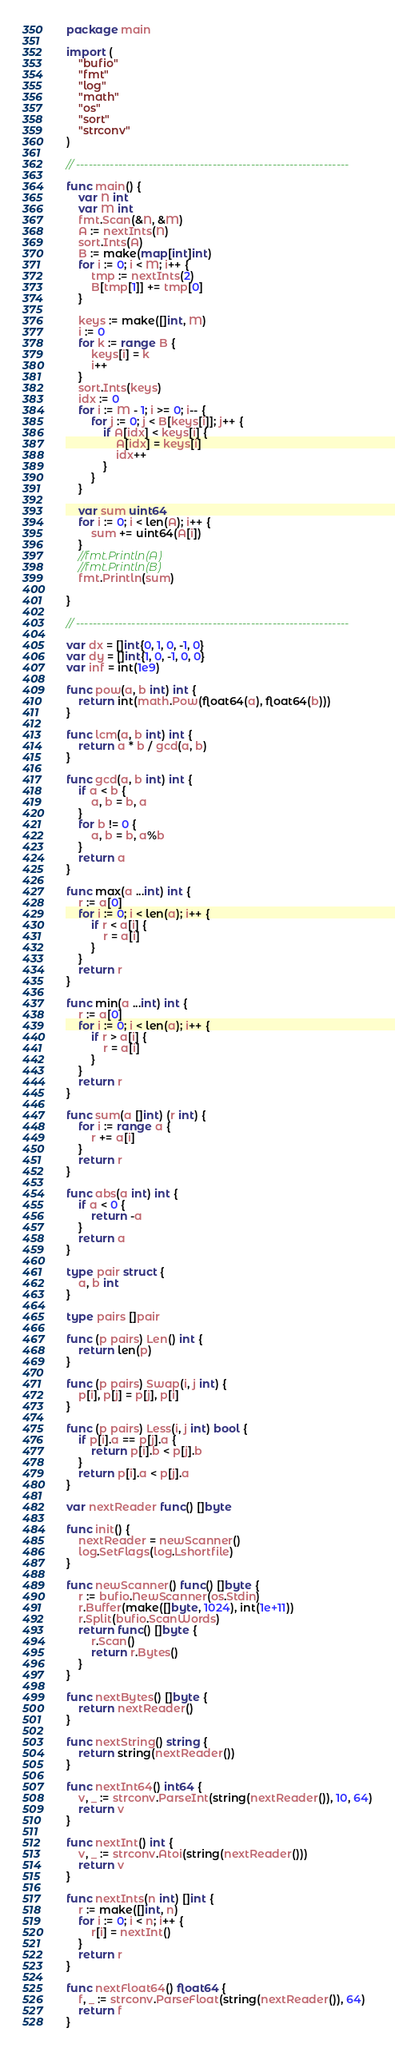<code> <loc_0><loc_0><loc_500><loc_500><_Go_>package main

import (
	"bufio"
	"fmt"
	"log"
	"math"
	"os"
	"sort"
	"strconv"
)

// ----------------------------------------------------------------

func main() {
	var N int
	var M int
	fmt.Scan(&N, &M)
	A := nextInts(N)
	sort.Ints(A)
	B := make(map[int]int)
	for i := 0; i < M; i++ {
		tmp := nextInts(2)
		B[tmp[1]] += tmp[0]
	}

	keys := make([]int, M)
	i := 0
	for k := range B {
		keys[i] = k
		i++
	}
	sort.Ints(keys)
	idx := 0
	for i := M - 1; i >= 0; i-- {
		for j := 0; j < B[keys[i]]; j++ {
			if A[idx] < keys[i] {
				A[idx] = keys[i]
				idx++
			}
		}
	}

	var sum uint64
	for i := 0; i < len(A); i++ {
		sum += uint64(A[i])
	}
	//fmt.Println(A)
	//fmt.Println(B)
	fmt.Println(sum)

}

// ----------------------------------------------------------------

var dx = []int{0, 1, 0, -1, 0}
var dy = []int{1, 0, -1, 0, 0}
var inf = int(1e9)

func pow(a, b int) int {
	return int(math.Pow(float64(a), float64(b)))
}

func lcm(a, b int) int {
	return a * b / gcd(a, b)
}

func gcd(a, b int) int {
	if a < b {
		a, b = b, a
	}
	for b != 0 {
		a, b = b, a%b
	}
	return a
}

func max(a ...int) int {
	r := a[0]
	for i := 0; i < len(a); i++ {
		if r < a[i] {
			r = a[i]
		}
	}
	return r
}

func min(a ...int) int {
	r := a[0]
	for i := 0; i < len(a); i++ {
		if r > a[i] {
			r = a[i]
		}
	}
	return r
}

func sum(a []int) (r int) {
	for i := range a {
		r += a[i]
	}
	return r
}

func abs(a int) int {
	if a < 0 {
		return -a
	}
	return a
}

type pair struct {
	a, b int
}

type pairs []pair

func (p pairs) Len() int {
	return len(p)
}

func (p pairs) Swap(i, j int) {
	p[i], p[j] = p[j], p[i]
}

func (p pairs) Less(i, j int) bool {
	if p[i].a == p[j].a {
		return p[i].b < p[j].b
	}
	return p[i].a < p[j].a
}

var nextReader func() []byte

func init() {
	nextReader = newScanner()
	log.SetFlags(log.Lshortfile)
}

func newScanner() func() []byte {
	r := bufio.NewScanner(os.Stdin)
	r.Buffer(make([]byte, 1024), int(1e+11))
	r.Split(bufio.ScanWords)
	return func() []byte {
		r.Scan()
		return r.Bytes()
	}
}

func nextBytes() []byte {
	return nextReader()
}

func nextString() string {
	return string(nextReader())
}

func nextInt64() int64 {
	v, _ := strconv.ParseInt(string(nextReader()), 10, 64)
	return v
}

func nextInt() int {
	v, _ := strconv.Atoi(string(nextReader()))
	return v
}

func nextInts(n int) []int {
	r := make([]int, n)
	for i := 0; i < n; i++ {
		r[i] = nextInt()
	}
	return r
}

func nextFloat64() float64 {
	f, _ := strconv.ParseFloat(string(nextReader()), 64)
	return f
}
</code> 